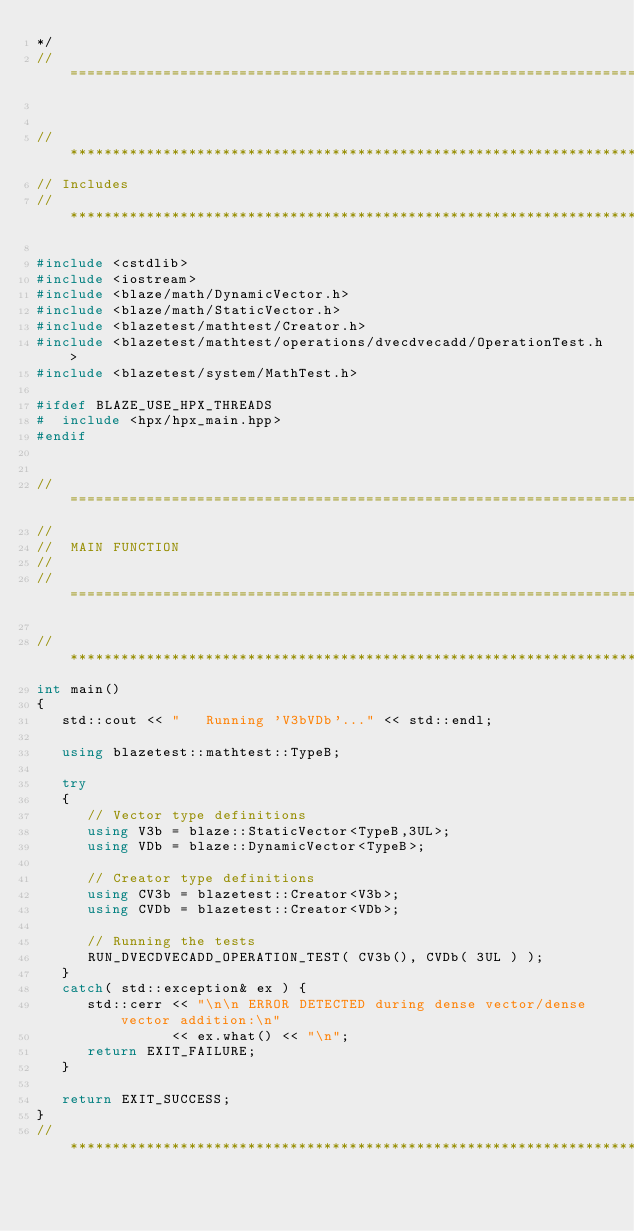Convert code to text. <code><loc_0><loc_0><loc_500><loc_500><_C++_>*/
//=================================================================================================


//*************************************************************************************************
// Includes
//*************************************************************************************************

#include <cstdlib>
#include <iostream>
#include <blaze/math/DynamicVector.h>
#include <blaze/math/StaticVector.h>
#include <blazetest/mathtest/Creator.h>
#include <blazetest/mathtest/operations/dvecdvecadd/OperationTest.h>
#include <blazetest/system/MathTest.h>

#ifdef BLAZE_USE_HPX_THREADS
#  include <hpx/hpx_main.hpp>
#endif


//=================================================================================================
//
//  MAIN FUNCTION
//
//=================================================================================================

//*************************************************************************************************
int main()
{
   std::cout << "   Running 'V3bVDb'..." << std::endl;

   using blazetest::mathtest::TypeB;

   try
   {
      // Vector type definitions
      using V3b = blaze::StaticVector<TypeB,3UL>;
      using VDb = blaze::DynamicVector<TypeB>;

      // Creator type definitions
      using CV3b = blazetest::Creator<V3b>;
      using CVDb = blazetest::Creator<VDb>;

      // Running the tests
      RUN_DVECDVECADD_OPERATION_TEST( CV3b(), CVDb( 3UL ) );
   }
   catch( std::exception& ex ) {
      std::cerr << "\n\n ERROR DETECTED during dense vector/dense vector addition:\n"
                << ex.what() << "\n";
      return EXIT_FAILURE;
   }

   return EXIT_SUCCESS;
}
//*************************************************************************************************
</code> 